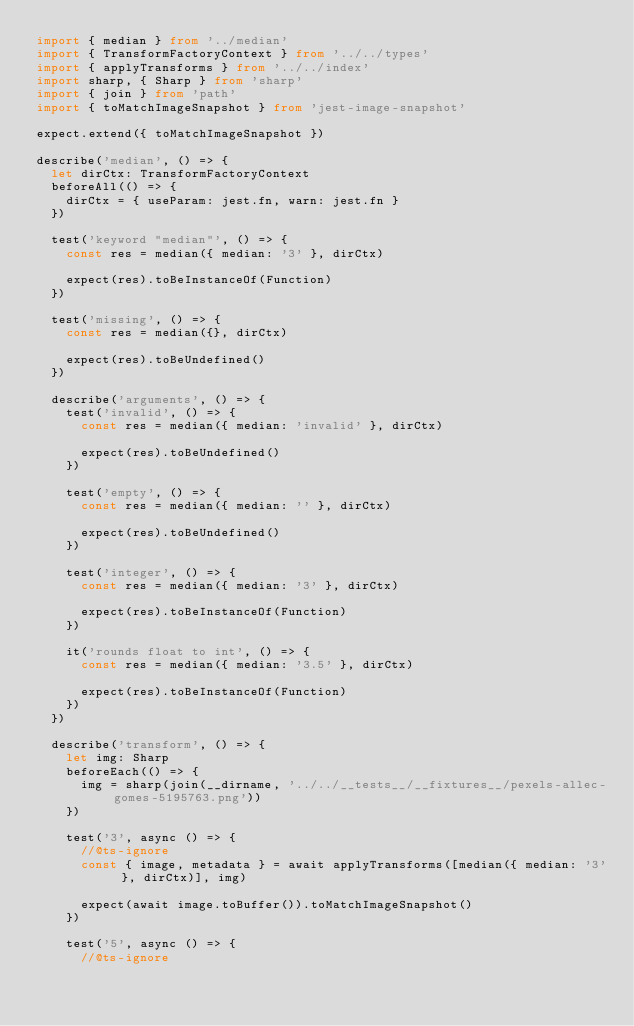Convert code to text. <code><loc_0><loc_0><loc_500><loc_500><_TypeScript_>import { median } from '../median'
import { TransformFactoryContext } from '../../types'
import { applyTransforms } from '../../index'
import sharp, { Sharp } from 'sharp'
import { join } from 'path'
import { toMatchImageSnapshot } from 'jest-image-snapshot'

expect.extend({ toMatchImageSnapshot })

describe('median', () => {
  let dirCtx: TransformFactoryContext
  beforeAll(() => {
    dirCtx = { useParam: jest.fn, warn: jest.fn }
  })

  test('keyword "median"', () => {
    const res = median({ median: '3' }, dirCtx)

    expect(res).toBeInstanceOf(Function)
  })

  test('missing', () => {
    const res = median({}, dirCtx)

    expect(res).toBeUndefined()
  })

  describe('arguments', () => {
    test('invalid', () => {
      const res = median({ median: 'invalid' }, dirCtx)

      expect(res).toBeUndefined()
    })

    test('empty', () => {
      const res = median({ median: '' }, dirCtx)

      expect(res).toBeUndefined()
    })

    test('integer', () => {
      const res = median({ median: '3' }, dirCtx)

      expect(res).toBeInstanceOf(Function)
    })

    it('rounds float to int', () => {
      const res = median({ median: '3.5' }, dirCtx)

      expect(res).toBeInstanceOf(Function)
    })
  })

  describe('transform', () => {
    let img: Sharp
    beforeEach(() => {
      img = sharp(join(__dirname, '../../__tests__/__fixtures__/pexels-allec-gomes-5195763.png'))
    })

    test('3', async () => {
      //@ts-ignore
      const { image, metadata } = await applyTransforms([median({ median: '3' }, dirCtx)], img)

      expect(await image.toBuffer()).toMatchImageSnapshot()
    })

    test('5', async () => {
      //@ts-ignore</code> 